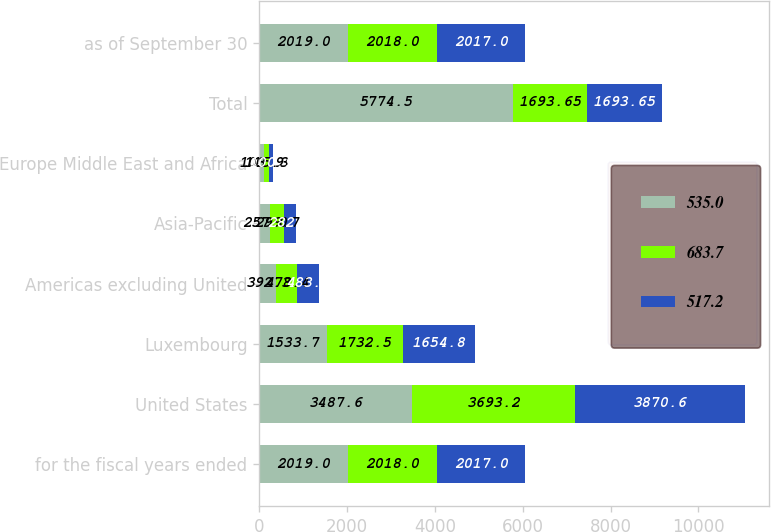Convert chart. <chart><loc_0><loc_0><loc_500><loc_500><stacked_bar_chart><ecel><fcel>for the fiscal years ended<fcel>United States<fcel>Luxembourg<fcel>Americas excluding United<fcel>Asia-Pacific<fcel>Europe Middle East and Africa<fcel>Total<fcel>as of September 30<nl><fcel>535<fcel>2019<fcel>3487.6<fcel>1533.7<fcel>392.3<fcel>257<fcel>103.9<fcel>5774.5<fcel>2019<nl><fcel>683.7<fcel>2018<fcel>3693.2<fcel>1732.5<fcel>478.4<fcel>299.7<fcel>115.3<fcel>1693.65<fcel>2018<nl><fcel>517.2<fcel>2017<fcel>3870.6<fcel>1654.8<fcel>483.3<fcel>282.6<fcel>100.9<fcel>1693.65<fcel>2017<nl></chart> 